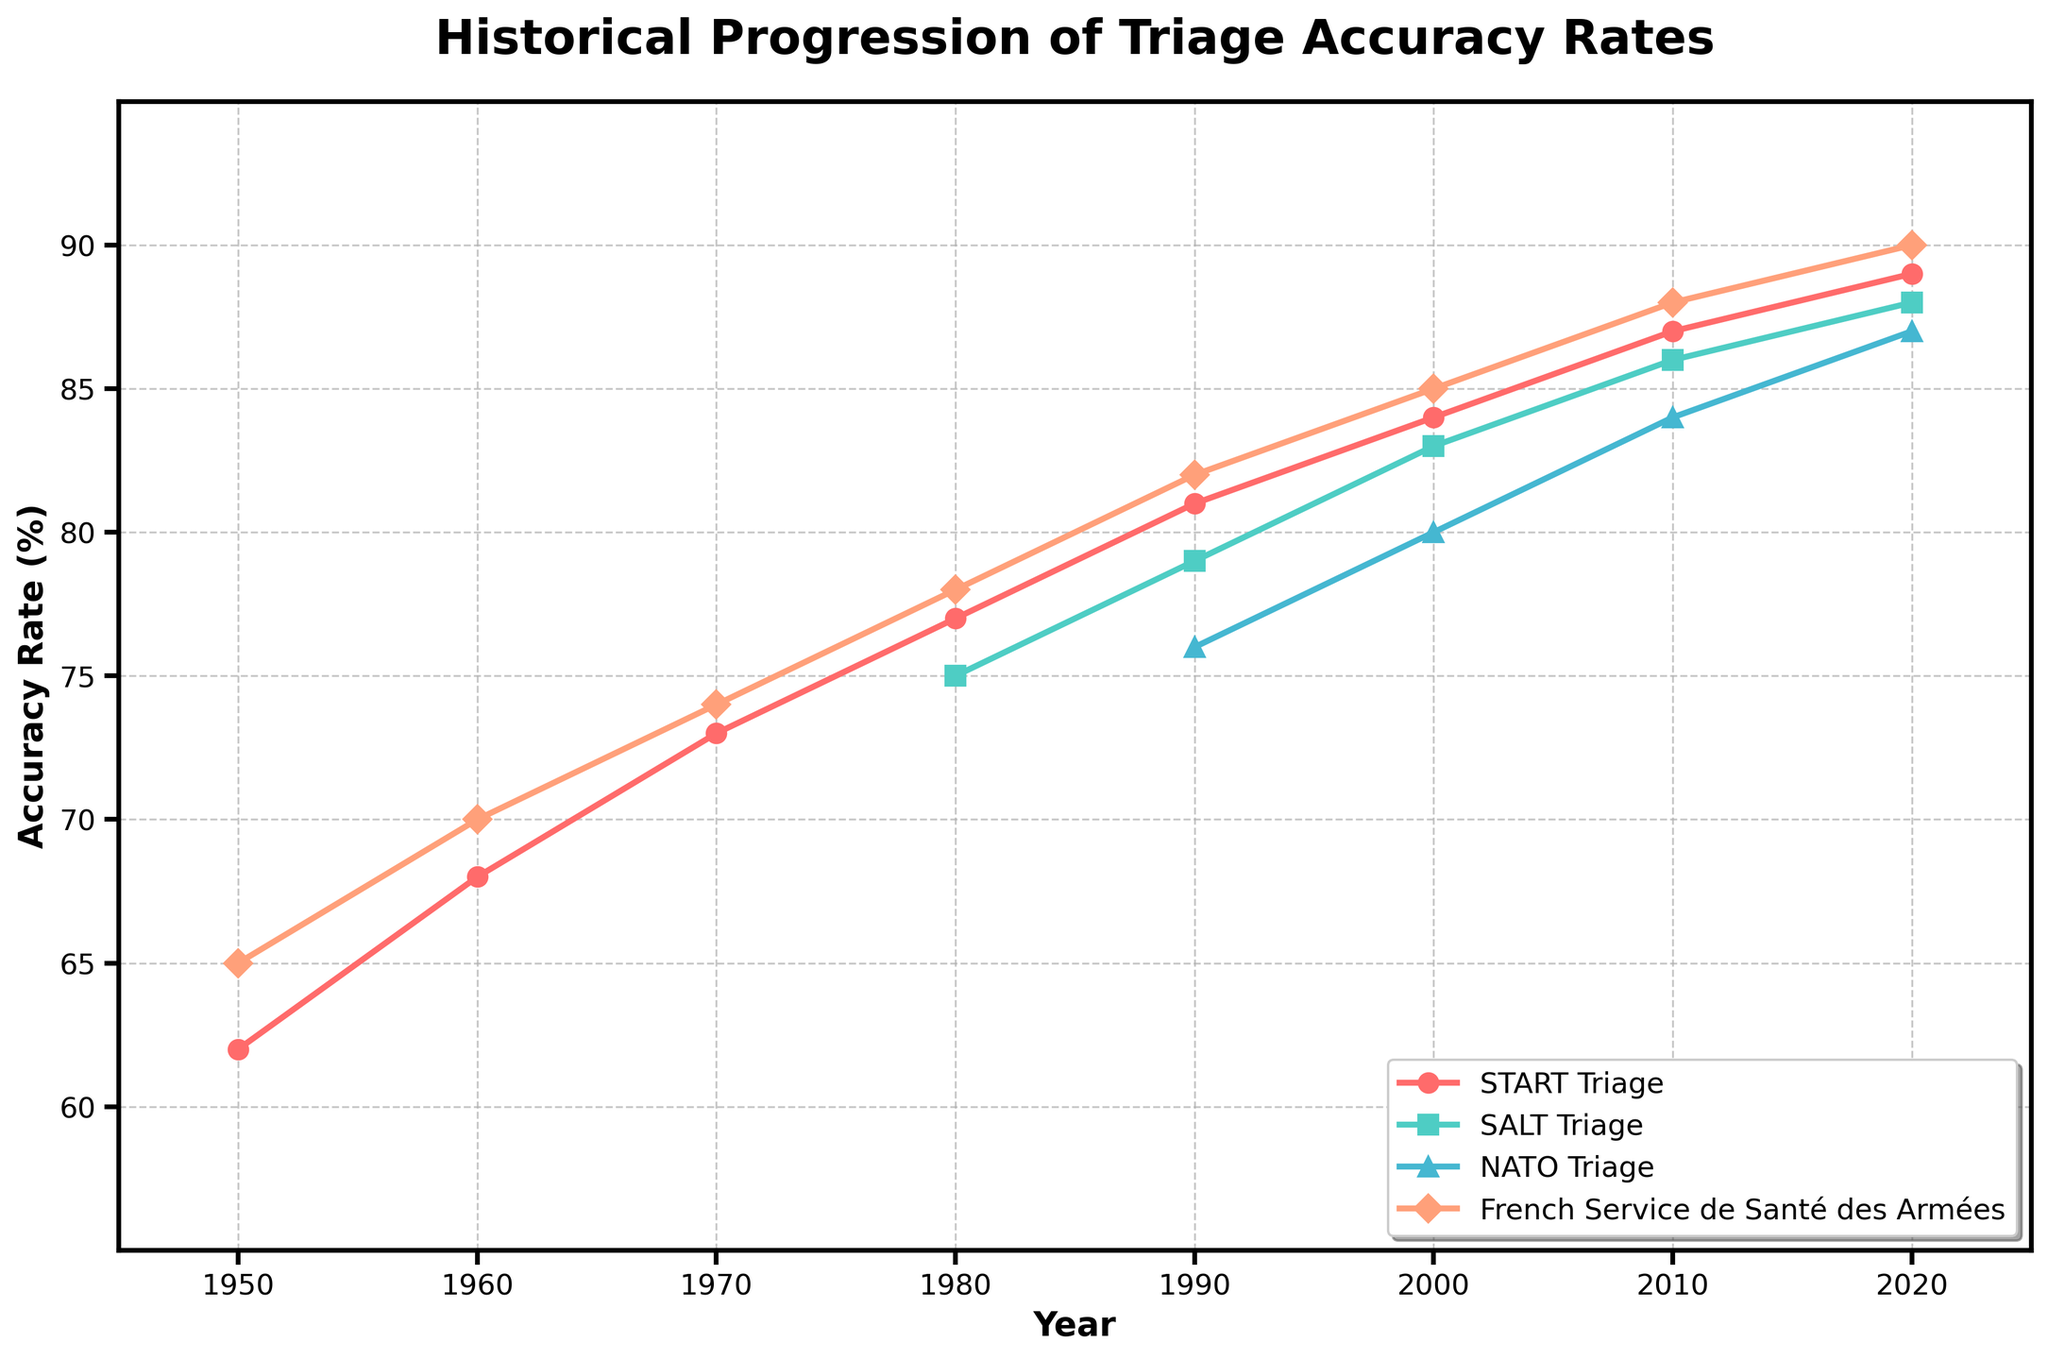What is the accuracy rate of the NATO Triage system in 2000? To find the accuracy rate of the NATO Triage system in 2000, locate the 2000 mark on the x-axis and read off the value for the NATO Triage system from the figure.
Answer: 80 Which triage system showed the largest increase in accuracy rate from 1980 to 1990? Compare the increase in accuracy rate from 1980 to 1990 for each system. Subtract the 1980 accuracy rate from the 1990 accuracy rate for each system and determine the largest difference.
Answer: French Service de Santé des Armées Between 1950 and 2020, which triage system consistently had the highest accuracy rate? Scan the lines representing all four triage systems in the figure and identify which one maintained the highest value throughout the entire period.
Answer: French Service de Santé des Armées What was the average accuracy rate of the START Triage system between 1950 and 2020? Calculate the average by summing the accuracy rates of the START Triage system for each available data point and dividing by the number of data points. (62 + 68 + 73 + 77 + 81 + 84 + 87 + 89) / 8 = 621 / 8 = 77.625
Answer: 77.625 How does the accuracy rate of the SALT Triage system in 2020 compare to the French Service de Santé des Armées system in 1980? Compare the vertical positions of the data points for the SALT Triage system in 2020 and the French Service de Santé des Armées system in 1980. Read off the accuracy rates and determine the relationship.
Answer: The SALT Triage system in 2020 (88) is higher than the French Service de Santé des Armées in 1980 (78) What's the difference in accuracy rate between START Triage and NATO Triage systems in 2010? Find the accuracy rates for the START Triage and NATO Triage systems in 2010, then subtract the NATO Triage accuracy rate from the START Triage accuracy rate. (87 - 84)
Answer: 3 Which triage system had the slowest improvement in accuracy rate from 2000 to 2020? Calculate the improvement for each system by subtracting the 2000 accuracy rate from the 2020 accuracy rate, and identify the smallest increase.
Answer: NATO Triage What is the overall trend in accuracy rates for the systems over the years? Observe the general direction of the lines representing the accuracy rates over time, noting whether they are rising, falling, or remaining steady. Each line generally increases from left to right.
Answer: Increasing How many triage systems had an accuracy rate below 80% in 1990? Examine the data points for 1990, count how many systems have values below 80%. Only one system, NATO Triage, had an accuracy rate below 80% in 1990.
Answer: 1 